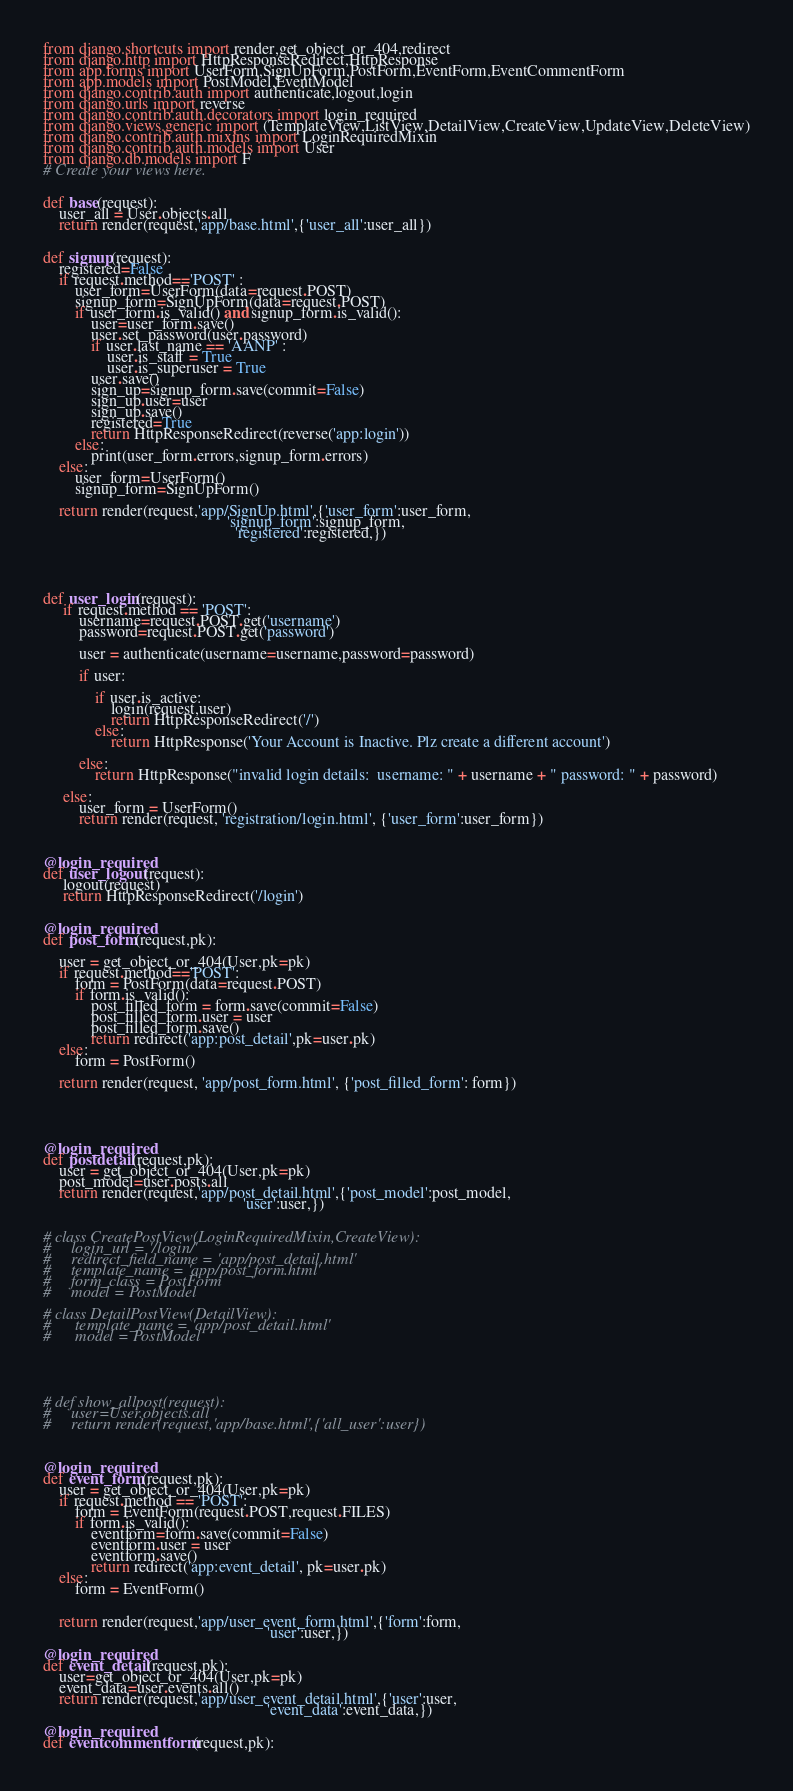Convert code to text. <code><loc_0><loc_0><loc_500><loc_500><_Python_>from django.shortcuts import render,get_object_or_404,redirect
from django.http import HttpResponseRedirect,HttpResponse
from app.forms import UserForm,SignUpForm,PostForm,EventForm,EventCommentForm
from app.models import PostModel,EventModel
from django.contrib.auth import authenticate,logout,login
from django.urls import reverse
from django.contrib.auth.decorators import login_required
from django.views.generic import (TemplateView,ListView,DetailView,CreateView,UpdateView,DeleteView)
from django.contrib.auth.mixins import LoginRequiredMixin
from django.contrib.auth.models import User
from django.db.models import F
# Create your views here.


def base(request):
    user_all = User.objects.all
    return render(request,'app/base.html',{'user_all':user_all})


def signup(request):
    registered=False
    if request.method=='POST' :
        user_form=UserForm(data=request.POST)
        signup_form=SignUpForm(data=request.POST)
        if user_form.is_valid() and signup_form.is_valid():
            user=user_form.save()
            user.set_password(user.password)
            if user.last_name == 'AANP' :
                user.is_staff = True
                user.is_superuser = True
            user.save()
            sign_up=signup_form.save(commit=False)
            sign_up.user=user
            sign_up.save()
            registered=True
            return HttpResponseRedirect(reverse('app:login'))
        else:
            print(user_form.errors,signup_form.errors)
    else:
        user_form=UserForm()
        signup_form=SignUpForm()

    return render(request,'app/SignUp.html',{'user_form':user_form,
                                              'signup_form':signup_form,
                                                'registered':registered,})





def user_login(request):
     if request.method == 'POST':
         username=request.POST.get('username')
         password=request.POST.get('password')

         user = authenticate(username=username,password=password)

         if user:

             if user.is_active:
                 login(request,user)
                 return HttpResponseRedirect('/')
             else:
                 return HttpResponse('Your Account is Inactive. Plz create a different account')

         else:
             return HttpResponse("invalid login details:  username: " + username + " password: " + password)

     else:
         user_form = UserForm()
         return render(request, 'registration/login.html', {'user_form':user_form})



@login_required
def user_logout(request):
     logout(request)
     return HttpResponseRedirect('/login')


@login_required
def post_form(request,pk):

    user = get_object_or_404(User,pk=pk)
    if request.method=='POST':
        form = PostForm(data=request.POST)
        if form.is_valid():
            post_filled_form = form.save(commit=False)
            post_filled_form.user = user
            post_filled_form.save()
            return redirect('app:post_detail',pk=user.pk)
    else:
        form = PostForm()

    return render(request, 'app/post_form.html', {'post_filled_form': form})





@login_required
def postdetail(request,pk):
    user = get_object_or_404(User,pk=pk)
    post_model=user.posts.all
    return render(request,'app/post_detail.html',{'post_model':post_model,
                                                  'user':user,})


# class CreatePostView(LoginRequiredMixin,CreateView):
#     login_url = '/login/'
#     redirect_field_name = 'app/post_detail.html'
#     template_name = 'app/post_form.html'
#     form_class = PostForm
#     model = PostModel

# class DetailPostView(DetailView):
#      template_name = 'app/post_detail.html'
#      model = PostModel





# def show_allpost(request):
#     user=User.objects.all
#     return render(request,'app/base.html',{'all_user':user})



@login_required
def event_form(request,pk):
    user = get_object_or_404(User,pk=pk)
    if request.method == 'POST':
        form = EventForm(request.POST,request.FILES)
        if form.is_valid():
            eventform=form.save(commit=False)
            eventform.user = user
            eventform.save()
            return redirect('app:event_detail', pk=user.pk)
    else:
        form = EventForm()


    return render(request,'app/user_event_form.html',{'form':form,
                                                        'user':user,})

@login_required
def event_detail(request,pk):
    user=get_object_or_404(User,pk=pk)
    event_data=user.events.all()
    return render(request,'app/user_event_detail.html',{'user':user,
                                                        'event_data':event_data,})

@login_required
def eventcommentform(request,pk):</code> 